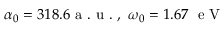<formula> <loc_0><loc_0><loc_500><loc_500>\alpha _ { 0 } = 3 1 8 . 6 a . u . , \ \omega _ { 0 } = 1 . 6 7 \ e V</formula> 